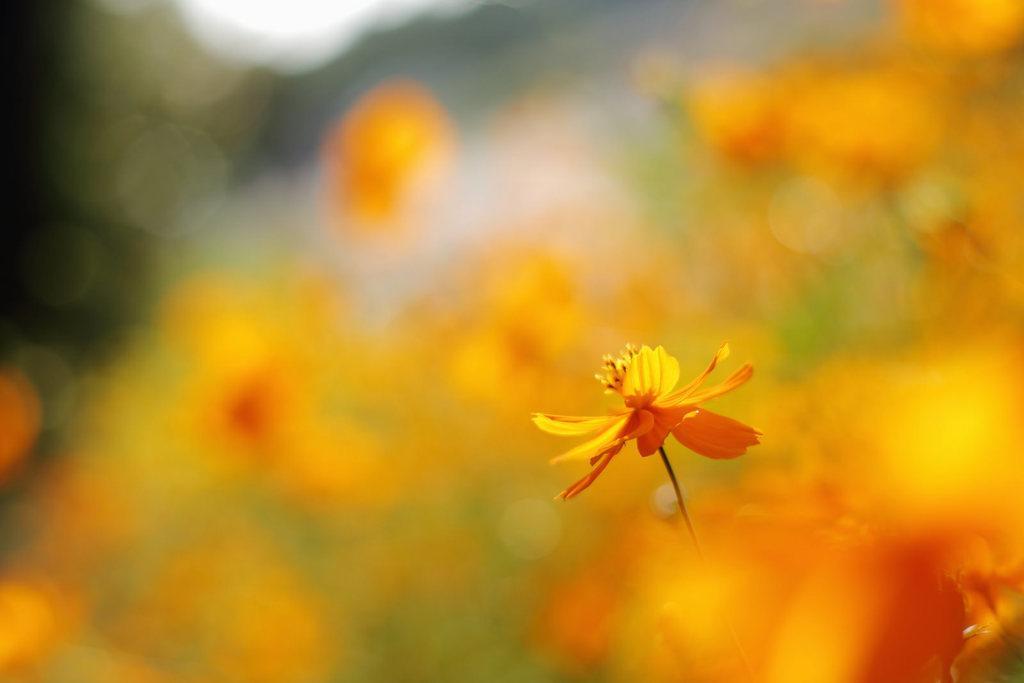In one or two sentences, can you explain what this image depicts? In this picture we can observe an orange color flower. The background is in orange color which is completely blurred. 